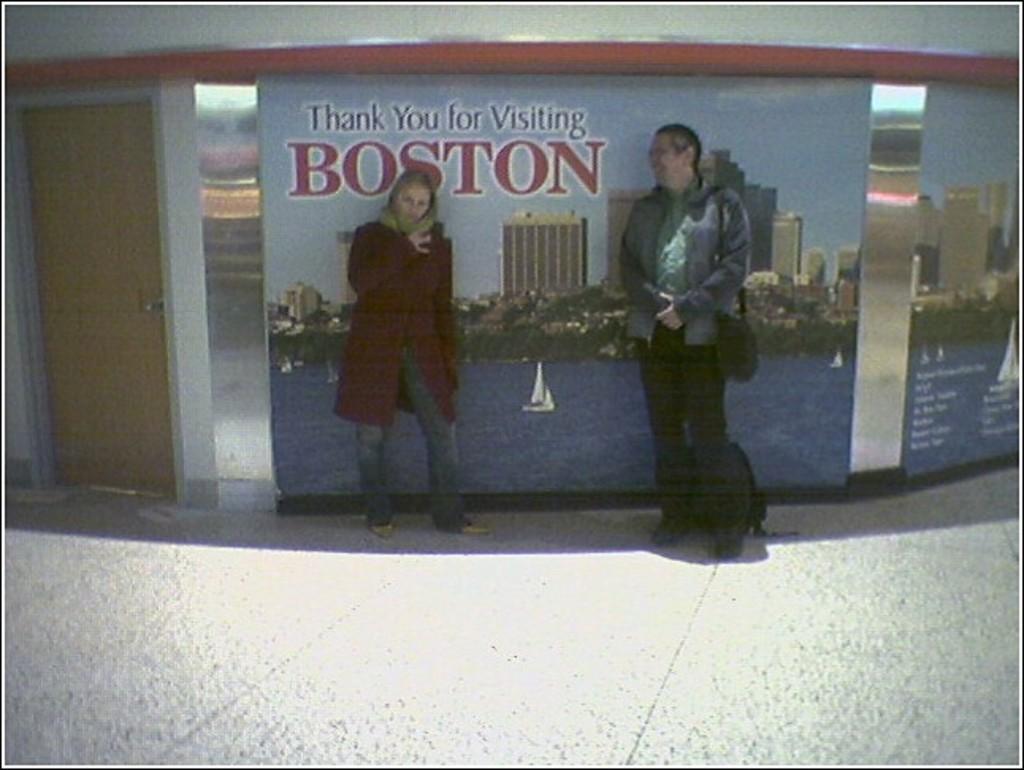In one or two sentences, can you explain what this image depicts? In this picture I can see two persons standing, there are boards to the wall and there is a door. 